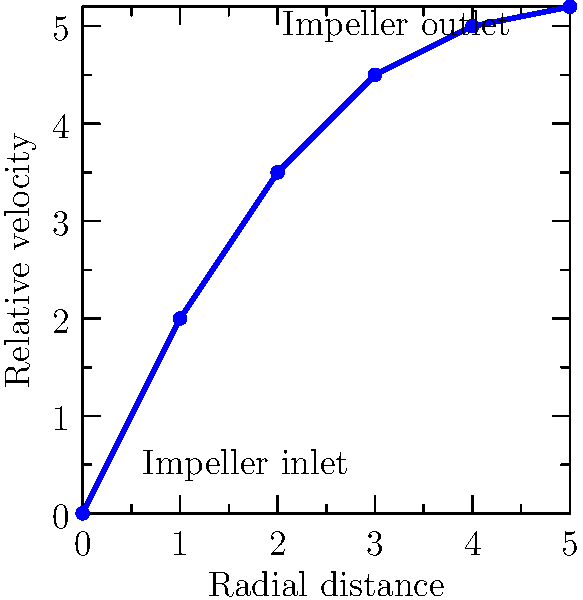As an entrepreneur in the pump manufacturing industry, you're analyzing the flow patterns in a centrifugal pump impeller. The graph shows the relative velocity of the fluid as a function of radial distance from the impeller center. What does the shape of this curve indicate about the flow behavior within the impeller, and how might this impact the pump's performance? To understand the flow behavior and its impact on pump performance, let's analyze the graph step-by-step:

1. Inlet region (0-1 on x-axis):
   The steep initial rise indicates rapid acceleration of the fluid as it enters the impeller. This is crucial for efficient energy transfer from the impeller to the fluid.

2. Mid-section (1-3 on x-axis):
   The curve shows a gradual increase in relative velocity. This suggests a steady acceleration of the fluid through the impeller passages, which is desirable for maintaining flow stability and reducing turbulence.

3. Outlet region (3-5 on x-axis):
   The curve begins to flatten, indicating a reduction in acceleration rate. This is typical near the impeller outlet where the fluid approaches its maximum velocity.

4. Overall shape:
   The smooth, monotonically increasing curve suggests a well-designed impeller with minimal flow separation or recirculation zones, which could otherwise reduce efficiency.

5. Performance implications:
   a) Efficiency: The gradual acceleration throughout the impeller suggests good energy transfer from the impeller to the fluid, potentially leading to high hydraulic efficiency.
   b) Cavitation resistance: The smooth acceleration reduces the risk of localized low-pressure areas, enhancing cavitation resistance.
   c) Wear and tear: A stable flow pattern with minimal turbulence can reduce wear on impeller surfaces, potentially increasing the pump's lifespan.
   d) Noise and vibration: Smooth flow patterns typically result in lower noise and vibration levels during operation.

6. Design considerations:
   The curve shape suggests an impeller design with:
   - Well-contoured vanes to guide the flow smoothly
   - Appropriate blade angle variations from inlet to outlet
   - Optimized passage width to maintain desired velocity increase

In conclusion, the flow pattern indicated by this velocity profile suggests a well-designed impeller that should contribute to good overall pump performance in terms of efficiency, reliability, and operating characteristics.
Answer: Smooth, gradual acceleration of fluid through the impeller, indicating efficient energy transfer, stable flow, and potentially high hydraulic efficiency with good cavitation resistance. 